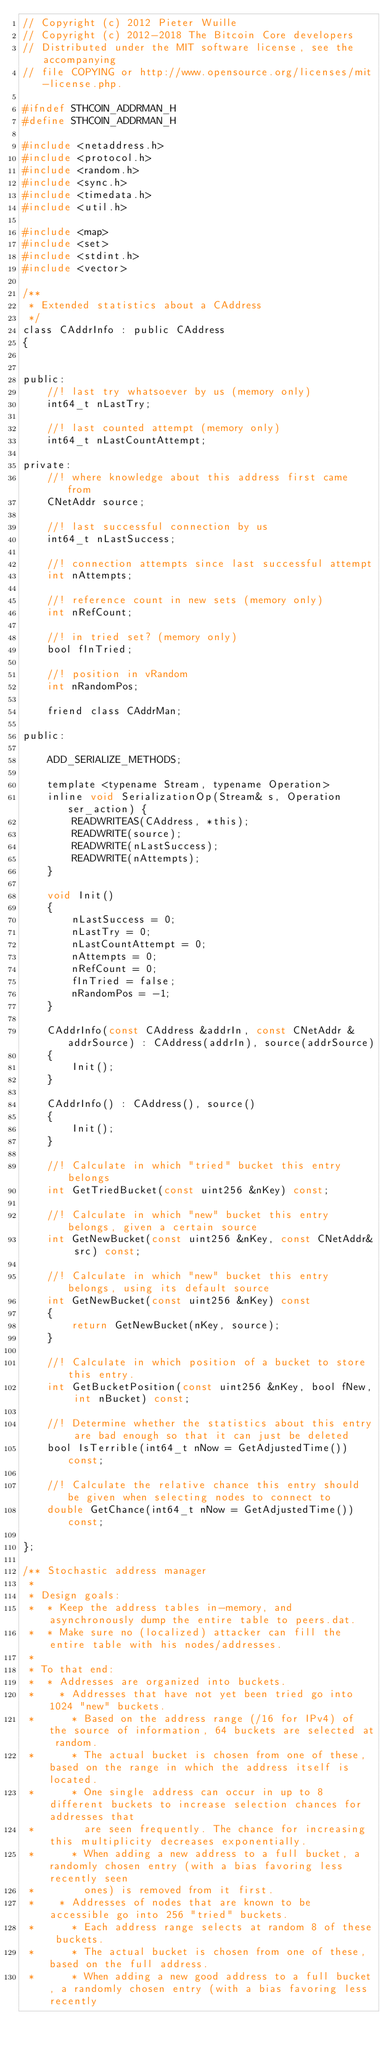Convert code to text. <code><loc_0><loc_0><loc_500><loc_500><_C_>// Copyright (c) 2012 Pieter Wuille
// Copyright (c) 2012-2018 The Bitcoin Core developers
// Distributed under the MIT software license, see the accompanying
// file COPYING or http://www.opensource.org/licenses/mit-license.php.

#ifndef STHCOIN_ADDRMAN_H
#define STHCOIN_ADDRMAN_H

#include <netaddress.h>
#include <protocol.h>
#include <random.h>
#include <sync.h>
#include <timedata.h>
#include <util.h>

#include <map>
#include <set>
#include <stdint.h>
#include <vector>

/**
 * Extended statistics about a CAddress
 */
class CAddrInfo : public CAddress
{


public:
    //! last try whatsoever by us (memory only)
    int64_t nLastTry;

    //! last counted attempt (memory only)
    int64_t nLastCountAttempt;

private:
    //! where knowledge about this address first came from
    CNetAddr source;

    //! last successful connection by us
    int64_t nLastSuccess;

    //! connection attempts since last successful attempt
    int nAttempts;

    //! reference count in new sets (memory only)
    int nRefCount;

    //! in tried set? (memory only)
    bool fInTried;

    //! position in vRandom
    int nRandomPos;

    friend class CAddrMan;

public:

    ADD_SERIALIZE_METHODS;

    template <typename Stream, typename Operation>
    inline void SerializationOp(Stream& s, Operation ser_action) {
        READWRITEAS(CAddress, *this);
        READWRITE(source);
        READWRITE(nLastSuccess);
        READWRITE(nAttempts);
    }

    void Init()
    {
        nLastSuccess = 0;
        nLastTry = 0;
        nLastCountAttempt = 0;
        nAttempts = 0;
        nRefCount = 0;
        fInTried = false;
        nRandomPos = -1;
    }

    CAddrInfo(const CAddress &addrIn, const CNetAddr &addrSource) : CAddress(addrIn), source(addrSource)
    {
        Init();
    }

    CAddrInfo() : CAddress(), source()
    {
        Init();
    }

    //! Calculate in which "tried" bucket this entry belongs
    int GetTriedBucket(const uint256 &nKey) const;

    //! Calculate in which "new" bucket this entry belongs, given a certain source
    int GetNewBucket(const uint256 &nKey, const CNetAddr& src) const;

    //! Calculate in which "new" bucket this entry belongs, using its default source
    int GetNewBucket(const uint256 &nKey) const
    {
        return GetNewBucket(nKey, source);
    }

    //! Calculate in which position of a bucket to store this entry.
    int GetBucketPosition(const uint256 &nKey, bool fNew, int nBucket) const;

    //! Determine whether the statistics about this entry are bad enough so that it can just be deleted
    bool IsTerrible(int64_t nNow = GetAdjustedTime()) const;

    //! Calculate the relative chance this entry should be given when selecting nodes to connect to
    double GetChance(int64_t nNow = GetAdjustedTime()) const;

};

/** Stochastic address manager
 *
 * Design goals:
 *  * Keep the address tables in-memory, and asynchronously dump the entire table to peers.dat.
 *  * Make sure no (localized) attacker can fill the entire table with his nodes/addresses.
 *
 * To that end:
 *  * Addresses are organized into buckets.
 *    * Addresses that have not yet been tried go into 1024 "new" buckets.
 *      * Based on the address range (/16 for IPv4) of the source of information, 64 buckets are selected at random.
 *      * The actual bucket is chosen from one of these, based on the range in which the address itself is located.
 *      * One single address can occur in up to 8 different buckets to increase selection chances for addresses that
 *        are seen frequently. The chance for increasing this multiplicity decreases exponentially.
 *      * When adding a new address to a full bucket, a randomly chosen entry (with a bias favoring less recently seen
 *        ones) is removed from it first.
 *    * Addresses of nodes that are known to be accessible go into 256 "tried" buckets.
 *      * Each address range selects at random 8 of these buckets.
 *      * The actual bucket is chosen from one of these, based on the full address.
 *      * When adding a new good address to a full bucket, a randomly chosen entry (with a bias favoring less recently</code> 